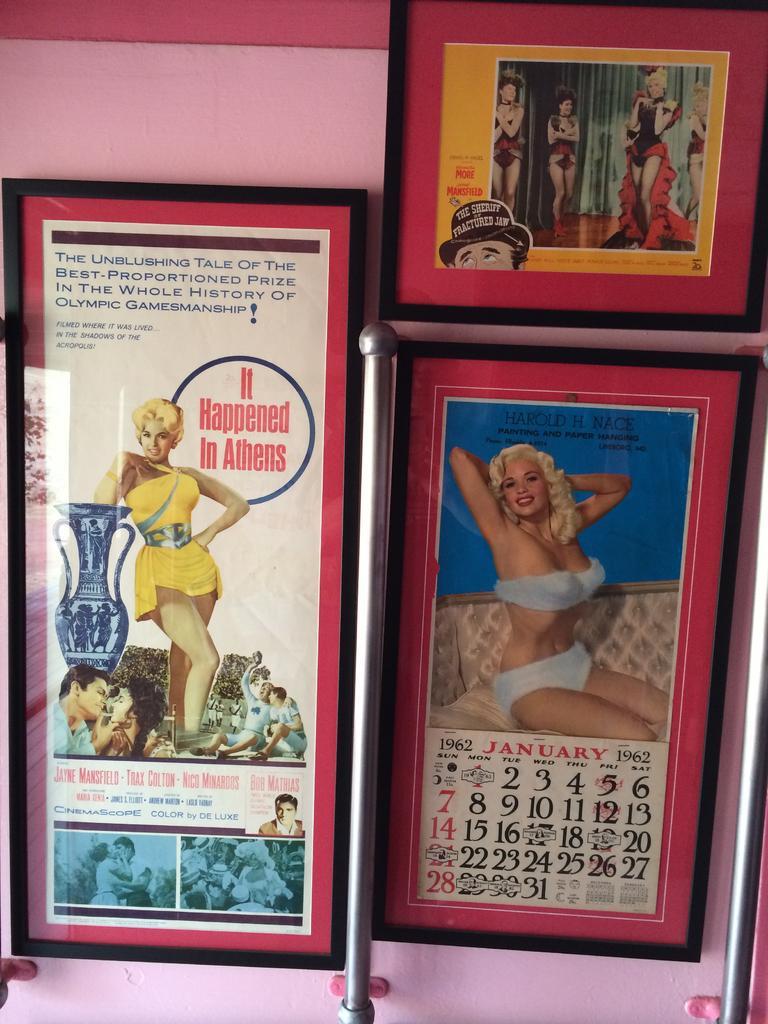Can you describe this image briefly? In this image we can see some frames on a wall containing pictures and some text on them. We can also see the metal poles. 